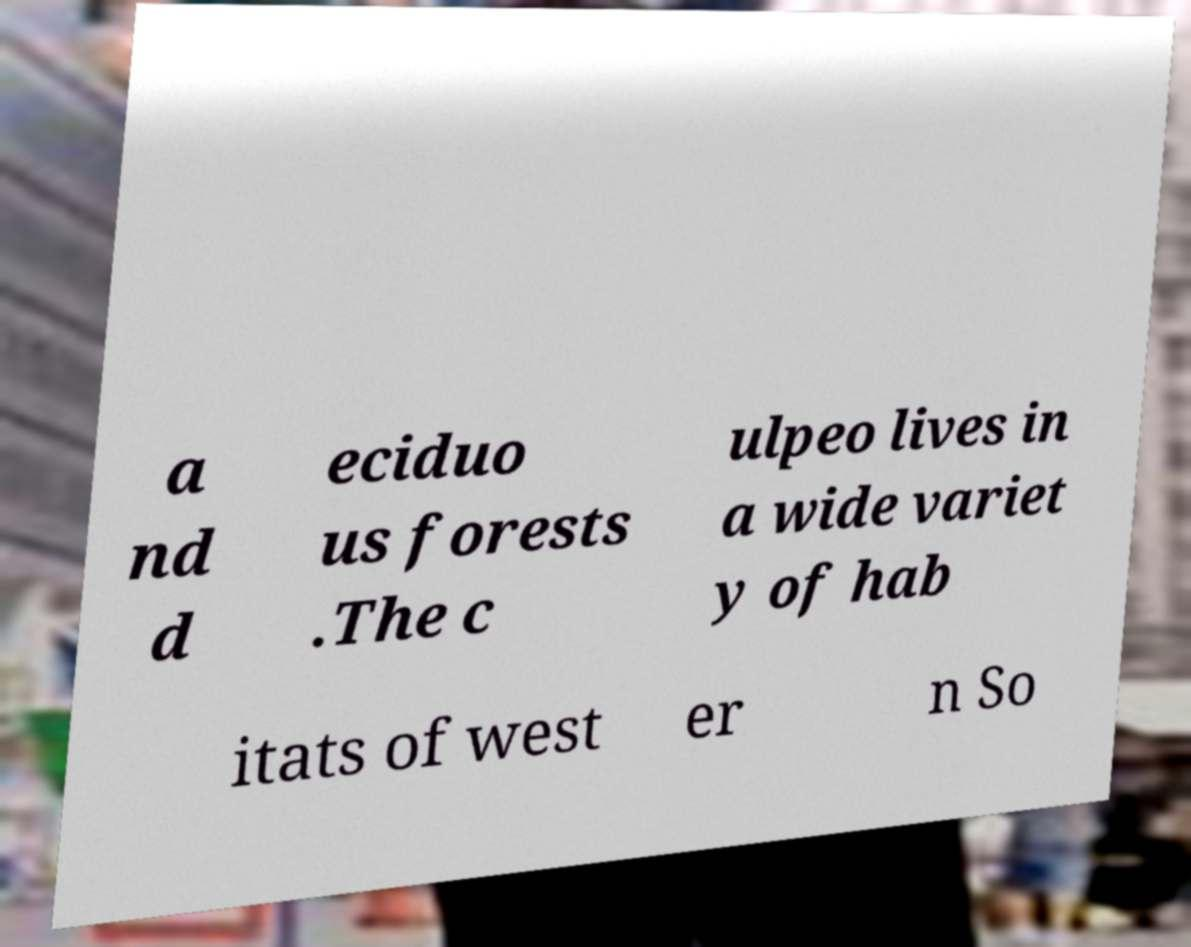Please read and relay the text visible in this image. What does it say? a nd d eciduo us forests .The c ulpeo lives in a wide variet y of hab itats of west er n So 